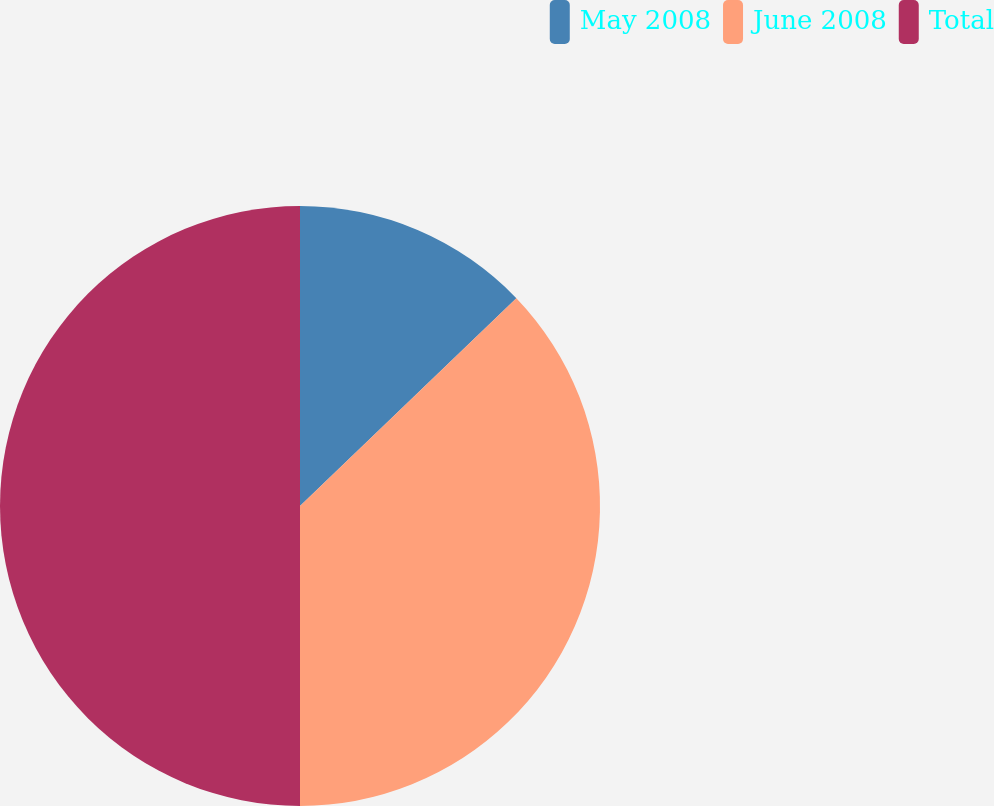<chart> <loc_0><loc_0><loc_500><loc_500><pie_chart><fcel>May 2008<fcel>June 2008<fcel>Total<nl><fcel>12.82%<fcel>37.18%<fcel>50.0%<nl></chart> 